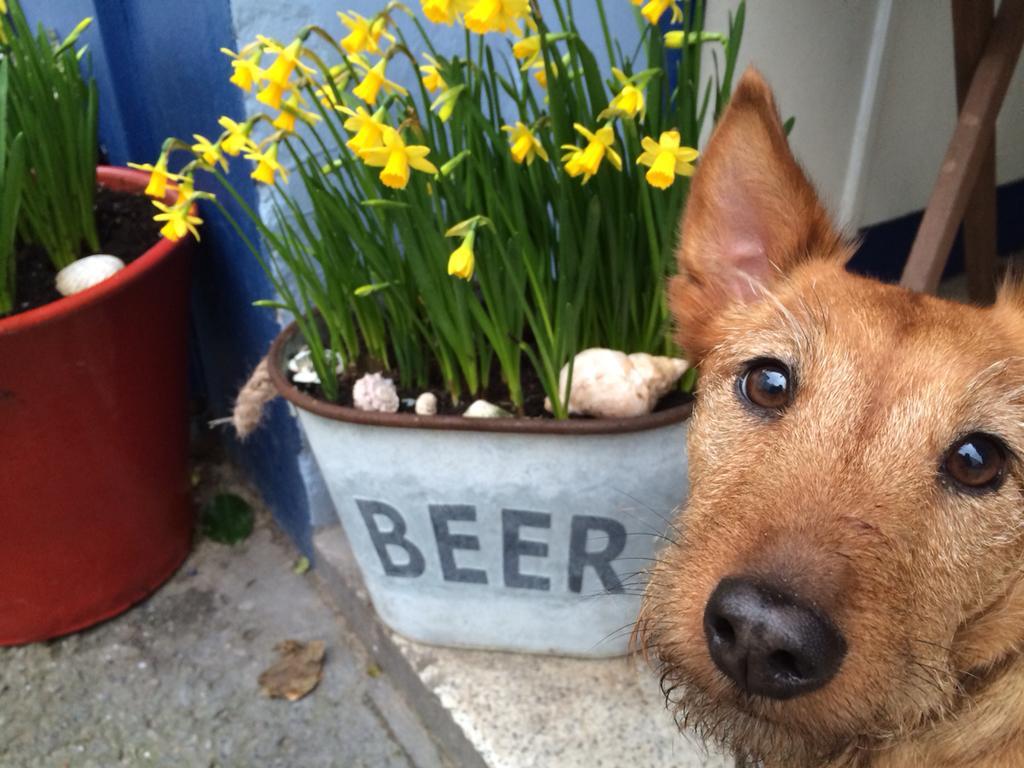Please provide a concise description of this image. In this picture I can see the dog's face, beside that I can see some yellow flowers on the plants. On the left I can see the red pot near to the wall. On the top right corner I can see the steel pipe near to the door. At the bottom there is a leaf. 